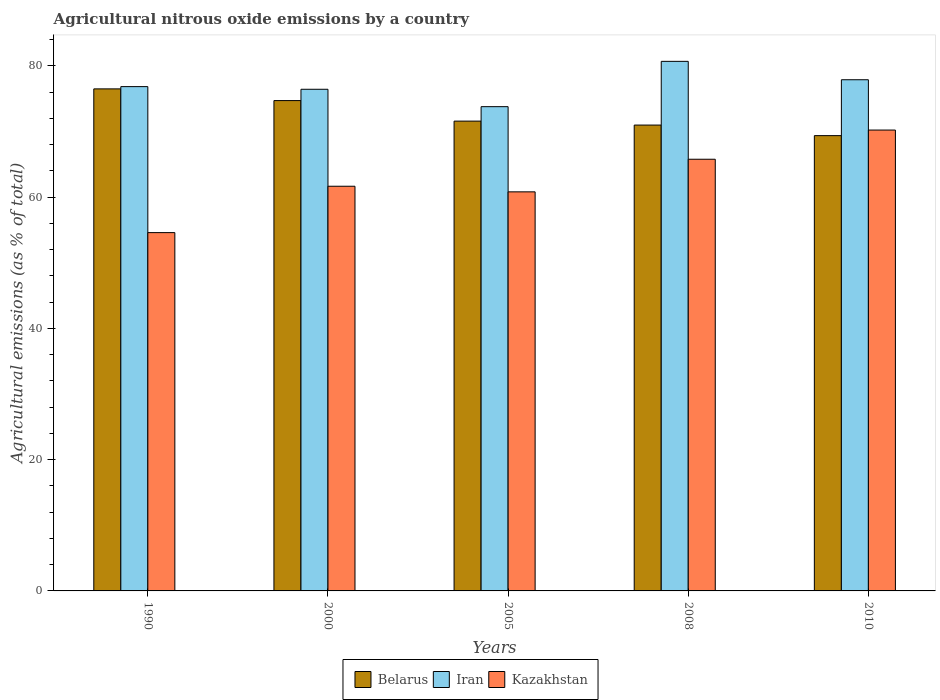How many different coloured bars are there?
Ensure brevity in your answer.  3. Are the number of bars per tick equal to the number of legend labels?
Offer a terse response. Yes. Are the number of bars on each tick of the X-axis equal?
Your answer should be compact. Yes. How many bars are there on the 2nd tick from the left?
Your answer should be compact. 3. How many bars are there on the 4th tick from the right?
Provide a short and direct response. 3. What is the amount of agricultural nitrous oxide emitted in Kazakhstan in 2008?
Your answer should be compact. 65.78. Across all years, what is the maximum amount of agricultural nitrous oxide emitted in Kazakhstan?
Give a very brief answer. 70.22. Across all years, what is the minimum amount of agricultural nitrous oxide emitted in Belarus?
Provide a succinct answer. 69.37. In which year was the amount of agricultural nitrous oxide emitted in Kazakhstan maximum?
Keep it short and to the point. 2010. What is the total amount of agricultural nitrous oxide emitted in Belarus in the graph?
Offer a terse response. 363.16. What is the difference between the amount of agricultural nitrous oxide emitted in Kazakhstan in 2000 and that in 2008?
Offer a terse response. -4.11. What is the difference between the amount of agricultural nitrous oxide emitted in Iran in 2000 and the amount of agricultural nitrous oxide emitted in Belarus in 2010?
Ensure brevity in your answer.  7.07. What is the average amount of agricultural nitrous oxide emitted in Kazakhstan per year?
Offer a terse response. 62.61. In the year 2008, what is the difference between the amount of agricultural nitrous oxide emitted in Kazakhstan and amount of agricultural nitrous oxide emitted in Belarus?
Your answer should be compact. -5.21. What is the ratio of the amount of agricultural nitrous oxide emitted in Belarus in 1990 to that in 2008?
Offer a very short reply. 1.08. Is the amount of agricultural nitrous oxide emitted in Kazakhstan in 2000 less than that in 2008?
Your response must be concise. Yes. What is the difference between the highest and the second highest amount of agricultural nitrous oxide emitted in Iran?
Offer a very short reply. 2.8. What is the difference between the highest and the lowest amount of agricultural nitrous oxide emitted in Kazakhstan?
Provide a succinct answer. 15.63. What does the 3rd bar from the left in 2000 represents?
Make the answer very short. Kazakhstan. What does the 3rd bar from the right in 2008 represents?
Provide a succinct answer. Belarus. How many bars are there?
Provide a short and direct response. 15. Are all the bars in the graph horizontal?
Provide a short and direct response. No. How many years are there in the graph?
Keep it short and to the point. 5. Are the values on the major ticks of Y-axis written in scientific E-notation?
Offer a terse response. No. Where does the legend appear in the graph?
Make the answer very short. Bottom center. How many legend labels are there?
Provide a succinct answer. 3. How are the legend labels stacked?
Keep it short and to the point. Horizontal. What is the title of the graph?
Give a very brief answer. Agricultural nitrous oxide emissions by a country. What is the label or title of the Y-axis?
Ensure brevity in your answer.  Agricultural emissions (as % of total). What is the Agricultural emissions (as % of total) in Belarus in 1990?
Your answer should be very brief. 76.5. What is the Agricultural emissions (as % of total) of Iran in 1990?
Give a very brief answer. 76.84. What is the Agricultural emissions (as % of total) in Kazakhstan in 1990?
Keep it short and to the point. 54.6. What is the Agricultural emissions (as % of total) in Belarus in 2000?
Your response must be concise. 74.72. What is the Agricultural emissions (as % of total) of Iran in 2000?
Your response must be concise. 76.44. What is the Agricultural emissions (as % of total) in Kazakhstan in 2000?
Ensure brevity in your answer.  61.66. What is the Agricultural emissions (as % of total) of Belarus in 2005?
Make the answer very short. 71.59. What is the Agricultural emissions (as % of total) in Iran in 2005?
Offer a terse response. 73.79. What is the Agricultural emissions (as % of total) of Kazakhstan in 2005?
Offer a terse response. 60.81. What is the Agricultural emissions (as % of total) in Belarus in 2008?
Keep it short and to the point. 70.98. What is the Agricultural emissions (as % of total) in Iran in 2008?
Your answer should be compact. 80.69. What is the Agricultural emissions (as % of total) in Kazakhstan in 2008?
Ensure brevity in your answer.  65.78. What is the Agricultural emissions (as % of total) in Belarus in 2010?
Provide a short and direct response. 69.37. What is the Agricultural emissions (as % of total) of Iran in 2010?
Ensure brevity in your answer.  77.89. What is the Agricultural emissions (as % of total) of Kazakhstan in 2010?
Ensure brevity in your answer.  70.22. Across all years, what is the maximum Agricultural emissions (as % of total) in Belarus?
Offer a very short reply. 76.5. Across all years, what is the maximum Agricultural emissions (as % of total) in Iran?
Keep it short and to the point. 80.69. Across all years, what is the maximum Agricultural emissions (as % of total) in Kazakhstan?
Your answer should be compact. 70.22. Across all years, what is the minimum Agricultural emissions (as % of total) of Belarus?
Make the answer very short. 69.37. Across all years, what is the minimum Agricultural emissions (as % of total) of Iran?
Keep it short and to the point. 73.79. Across all years, what is the minimum Agricultural emissions (as % of total) of Kazakhstan?
Provide a short and direct response. 54.6. What is the total Agricultural emissions (as % of total) in Belarus in the graph?
Give a very brief answer. 363.16. What is the total Agricultural emissions (as % of total) of Iran in the graph?
Provide a short and direct response. 385.66. What is the total Agricultural emissions (as % of total) of Kazakhstan in the graph?
Provide a short and direct response. 313.07. What is the difference between the Agricultural emissions (as % of total) in Belarus in 1990 and that in 2000?
Keep it short and to the point. 1.78. What is the difference between the Agricultural emissions (as % of total) of Iran in 1990 and that in 2000?
Ensure brevity in your answer.  0.4. What is the difference between the Agricultural emissions (as % of total) of Kazakhstan in 1990 and that in 2000?
Your answer should be compact. -7.07. What is the difference between the Agricultural emissions (as % of total) of Belarus in 1990 and that in 2005?
Make the answer very short. 4.91. What is the difference between the Agricultural emissions (as % of total) of Iran in 1990 and that in 2005?
Ensure brevity in your answer.  3.06. What is the difference between the Agricultural emissions (as % of total) in Kazakhstan in 1990 and that in 2005?
Your answer should be compact. -6.21. What is the difference between the Agricultural emissions (as % of total) of Belarus in 1990 and that in 2008?
Make the answer very short. 5.51. What is the difference between the Agricultural emissions (as % of total) in Iran in 1990 and that in 2008?
Keep it short and to the point. -3.85. What is the difference between the Agricultural emissions (as % of total) in Kazakhstan in 1990 and that in 2008?
Ensure brevity in your answer.  -11.18. What is the difference between the Agricultural emissions (as % of total) of Belarus in 1990 and that in 2010?
Your answer should be compact. 7.12. What is the difference between the Agricultural emissions (as % of total) in Iran in 1990 and that in 2010?
Provide a short and direct response. -1.05. What is the difference between the Agricultural emissions (as % of total) in Kazakhstan in 1990 and that in 2010?
Provide a succinct answer. -15.63. What is the difference between the Agricultural emissions (as % of total) in Belarus in 2000 and that in 2005?
Ensure brevity in your answer.  3.13. What is the difference between the Agricultural emissions (as % of total) of Iran in 2000 and that in 2005?
Provide a short and direct response. 2.65. What is the difference between the Agricultural emissions (as % of total) of Kazakhstan in 2000 and that in 2005?
Give a very brief answer. 0.86. What is the difference between the Agricultural emissions (as % of total) of Belarus in 2000 and that in 2008?
Make the answer very short. 3.73. What is the difference between the Agricultural emissions (as % of total) in Iran in 2000 and that in 2008?
Keep it short and to the point. -4.25. What is the difference between the Agricultural emissions (as % of total) in Kazakhstan in 2000 and that in 2008?
Provide a succinct answer. -4.11. What is the difference between the Agricultural emissions (as % of total) in Belarus in 2000 and that in 2010?
Offer a terse response. 5.34. What is the difference between the Agricultural emissions (as % of total) in Iran in 2000 and that in 2010?
Your answer should be compact. -1.45. What is the difference between the Agricultural emissions (as % of total) of Kazakhstan in 2000 and that in 2010?
Make the answer very short. -8.56. What is the difference between the Agricultural emissions (as % of total) in Belarus in 2005 and that in 2008?
Your response must be concise. 0.6. What is the difference between the Agricultural emissions (as % of total) of Iran in 2005 and that in 2008?
Offer a very short reply. -6.91. What is the difference between the Agricultural emissions (as % of total) of Kazakhstan in 2005 and that in 2008?
Offer a terse response. -4.97. What is the difference between the Agricultural emissions (as % of total) in Belarus in 2005 and that in 2010?
Ensure brevity in your answer.  2.21. What is the difference between the Agricultural emissions (as % of total) in Iran in 2005 and that in 2010?
Provide a succinct answer. -4.1. What is the difference between the Agricultural emissions (as % of total) in Kazakhstan in 2005 and that in 2010?
Provide a short and direct response. -9.42. What is the difference between the Agricultural emissions (as % of total) in Belarus in 2008 and that in 2010?
Give a very brief answer. 1.61. What is the difference between the Agricultural emissions (as % of total) in Iran in 2008 and that in 2010?
Offer a terse response. 2.8. What is the difference between the Agricultural emissions (as % of total) in Kazakhstan in 2008 and that in 2010?
Offer a very short reply. -4.45. What is the difference between the Agricultural emissions (as % of total) in Belarus in 1990 and the Agricultural emissions (as % of total) in Iran in 2000?
Your response must be concise. 0.06. What is the difference between the Agricultural emissions (as % of total) in Belarus in 1990 and the Agricultural emissions (as % of total) in Kazakhstan in 2000?
Your response must be concise. 14.84. What is the difference between the Agricultural emissions (as % of total) of Iran in 1990 and the Agricultural emissions (as % of total) of Kazakhstan in 2000?
Your answer should be very brief. 15.18. What is the difference between the Agricultural emissions (as % of total) in Belarus in 1990 and the Agricultural emissions (as % of total) in Iran in 2005?
Ensure brevity in your answer.  2.71. What is the difference between the Agricultural emissions (as % of total) in Belarus in 1990 and the Agricultural emissions (as % of total) in Kazakhstan in 2005?
Offer a terse response. 15.69. What is the difference between the Agricultural emissions (as % of total) in Iran in 1990 and the Agricultural emissions (as % of total) in Kazakhstan in 2005?
Offer a terse response. 16.04. What is the difference between the Agricultural emissions (as % of total) of Belarus in 1990 and the Agricultural emissions (as % of total) of Iran in 2008?
Offer a very short reply. -4.2. What is the difference between the Agricultural emissions (as % of total) in Belarus in 1990 and the Agricultural emissions (as % of total) in Kazakhstan in 2008?
Keep it short and to the point. 10.72. What is the difference between the Agricultural emissions (as % of total) of Iran in 1990 and the Agricultural emissions (as % of total) of Kazakhstan in 2008?
Give a very brief answer. 11.07. What is the difference between the Agricultural emissions (as % of total) in Belarus in 1990 and the Agricultural emissions (as % of total) in Iran in 2010?
Make the answer very short. -1.39. What is the difference between the Agricultural emissions (as % of total) of Belarus in 1990 and the Agricultural emissions (as % of total) of Kazakhstan in 2010?
Offer a terse response. 6.27. What is the difference between the Agricultural emissions (as % of total) of Iran in 1990 and the Agricultural emissions (as % of total) of Kazakhstan in 2010?
Ensure brevity in your answer.  6.62. What is the difference between the Agricultural emissions (as % of total) in Belarus in 2000 and the Agricultural emissions (as % of total) in Iran in 2005?
Ensure brevity in your answer.  0.93. What is the difference between the Agricultural emissions (as % of total) of Belarus in 2000 and the Agricultural emissions (as % of total) of Kazakhstan in 2005?
Your response must be concise. 13.91. What is the difference between the Agricultural emissions (as % of total) in Iran in 2000 and the Agricultural emissions (as % of total) in Kazakhstan in 2005?
Offer a terse response. 15.63. What is the difference between the Agricultural emissions (as % of total) of Belarus in 2000 and the Agricultural emissions (as % of total) of Iran in 2008?
Keep it short and to the point. -5.98. What is the difference between the Agricultural emissions (as % of total) in Belarus in 2000 and the Agricultural emissions (as % of total) in Kazakhstan in 2008?
Ensure brevity in your answer.  8.94. What is the difference between the Agricultural emissions (as % of total) in Iran in 2000 and the Agricultural emissions (as % of total) in Kazakhstan in 2008?
Keep it short and to the point. 10.66. What is the difference between the Agricultural emissions (as % of total) in Belarus in 2000 and the Agricultural emissions (as % of total) in Iran in 2010?
Your response must be concise. -3.18. What is the difference between the Agricultural emissions (as % of total) of Belarus in 2000 and the Agricultural emissions (as % of total) of Kazakhstan in 2010?
Offer a very short reply. 4.49. What is the difference between the Agricultural emissions (as % of total) in Iran in 2000 and the Agricultural emissions (as % of total) in Kazakhstan in 2010?
Make the answer very short. 6.22. What is the difference between the Agricultural emissions (as % of total) in Belarus in 2005 and the Agricultural emissions (as % of total) in Iran in 2008?
Your answer should be compact. -9.11. What is the difference between the Agricultural emissions (as % of total) in Belarus in 2005 and the Agricultural emissions (as % of total) in Kazakhstan in 2008?
Offer a very short reply. 5.81. What is the difference between the Agricultural emissions (as % of total) in Iran in 2005 and the Agricultural emissions (as % of total) in Kazakhstan in 2008?
Provide a short and direct response. 8.01. What is the difference between the Agricultural emissions (as % of total) in Belarus in 2005 and the Agricultural emissions (as % of total) in Iran in 2010?
Your answer should be compact. -6.3. What is the difference between the Agricultural emissions (as % of total) of Belarus in 2005 and the Agricultural emissions (as % of total) of Kazakhstan in 2010?
Offer a terse response. 1.36. What is the difference between the Agricultural emissions (as % of total) in Iran in 2005 and the Agricultural emissions (as % of total) in Kazakhstan in 2010?
Your response must be concise. 3.56. What is the difference between the Agricultural emissions (as % of total) in Belarus in 2008 and the Agricultural emissions (as % of total) in Iran in 2010?
Ensure brevity in your answer.  -6.91. What is the difference between the Agricultural emissions (as % of total) in Belarus in 2008 and the Agricultural emissions (as % of total) in Kazakhstan in 2010?
Your answer should be compact. 0.76. What is the difference between the Agricultural emissions (as % of total) of Iran in 2008 and the Agricultural emissions (as % of total) of Kazakhstan in 2010?
Your answer should be compact. 10.47. What is the average Agricultural emissions (as % of total) of Belarus per year?
Ensure brevity in your answer.  72.63. What is the average Agricultural emissions (as % of total) in Iran per year?
Offer a terse response. 77.13. What is the average Agricultural emissions (as % of total) in Kazakhstan per year?
Provide a short and direct response. 62.61. In the year 1990, what is the difference between the Agricultural emissions (as % of total) in Belarus and Agricultural emissions (as % of total) in Iran?
Keep it short and to the point. -0.35. In the year 1990, what is the difference between the Agricultural emissions (as % of total) of Belarus and Agricultural emissions (as % of total) of Kazakhstan?
Your answer should be compact. 21.9. In the year 1990, what is the difference between the Agricultural emissions (as % of total) in Iran and Agricultural emissions (as % of total) in Kazakhstan?
Your answer should be very brief. 22.25. In the year 2000, what is the difference between the Agricultural emissions (as % of total) of Belarus and Agricultural emissions (as % of total) of Iran?
Your response must be concise. -1.73. In the year 2000, what is the difference between the Agricultural emissions (as % of total) of Belarus and Agricultural emissions (as % of total) of Kazakhstan?
Make the answer very short. 13.05. In the year 2000, what is the difference between the Agricultural emissions (as % of total) of Iran and Agricultural emissions (as % of total) of Kazakhstan?
Provide a succinct answer. 14.78. In the year 2005, what is the difference between the Agricultural emissions (as % of total) in Belarus and Agricultural emissions (as % of total) in Iran?
Provide a short and direct response. -2.2. In the year 2005, what is the difference between the Agricultural emissions (as % of total) of Belarus and Agricultural emissions (as % of total) of Kazakhstan?
Offer a very short reply. 10.78. In the year 2005, what is the difference between the Agricultural emissions (as % of total) in Iran and Agricultural emissions (as % of total) in Kazakhstan?
Ensure brevity in your answer.  12.98. In the year 2008, what is the difference between the Agricultural emissions (as % of total) in Belarus and Agricultural emissions (as % of total) in Iran?
Provide a short and direct response. -9.71. In the year 2008, what is the difference between the Agricultural emissions (as % of total) of Belarus and Agricultural emissions (as % of total) of Kazakhstan?
Keep it short and to the point. 5.21. In the year 2008, what is the difference between the Agricultural emissions (as % of total) of Iran and Agricultural emissions (as % of total) of Kazakhstan?
Your answer should be very brief. 14.92. In the year 2010, what is the difference between the Agricultural emissions (as % of total) in Belarus and Agricultural emissions (as % of total) in Iran?
Offer a very short reply. -8.52. In the year 2010, what is the difference between the Agricultural emissions (as % of total) in Belarus and Agricultural emissions (as % of total) in Kazakhstan?
Your answer should be very brief. -0.85. In the year 2010, what is the difference between the Agricultural emissions (as % of total) in Iran and Agricultural emissions (as % of total) in Kazakhstan?
Ensure brevity in your answer.  7.67. What is the ratio of the Agricultural emissions (as % of total) of Belarus in 1990 to that in 2000?
Your answer should be compact. 1.02. What is the ratio of the Agricultural emissions (as % of total) of Iran in 1990 to that in 2000?
Provide a succinct answer. 1.01. What is the ratio of the Agricultural emissions (as % of total) of Kazakhstan in 1990 to that in 2000?
Your response must be concise. 0.89. What is the ratio of the Agricultural emissions (as % of total) in Belarus in 1990 to that in 2005?
Offer a terse response. 1.07. What is the ratio of the Agricultural emissions (as % of total) of Iran in 1990 to that in 2005?
Your answer should be very brief. 1.04. What is the ratio of the Agricultural emissions (as % of total) of Kazakhstan in 1990 to that in 2005?
Your response must be concise. 0.9. What is the ratio of the Agricultural emissions (as % of total) of Belarus in 1990 to that in 2008?
Keep it short and to the point. 1.08. What is the ratio of the Agricultural emissions (as % of total) of Iran in 1990 to that in 2008?
Keep it short and to the point. 0.95. What is the ratio of the Agricultural emissions (as % of total) in Kazakhstan in 1990 to that in 2008?
Ensure brevity in your answer.  0.83. What is the ratio of the Agricultural emissions (as % of total) of Belarus in 1990 to that in 2010?
Offer a terse response. 1.1. What is the ratio of the Agricultural emissions (as % of total) of Iran in 1990 to that in 2010?
Provide a short and direct response. 0.99. What is the ratio of the Agricultural emissions (as % of total) in Kazakhstan in 1990 to that in 2010?
Provide a short and direct response. 0.78. What is the ratio of the Agricultural emissions (as % of total) in Belarus in 2000 to that in 2005?
Provide a short and direct response. 1.04. What is the ratio of the Agricultural emissions (as % of total) in Iran in 2000 to that in 2005?
Give a very brief answer. 1.04. What is the ratio of the Agricultural emissions (as % of total) of Kazakhstan in 2000 to that in 2005?
Your response must be concise. 1.01. What is the ratio of the Agricultural emissions (as % of total) of Belarus in 2000 to that in 2008?
Provide a short and direct response. 1.05. What is the ratio of the Agricultural emissions (as % of total) in Iran in 2000 to that in 2008?
Your answer should be compact. 0.95. What is the ratio of the Agricultural emissions (as % of total) in Kazakhstan in 2000 to that in 2008?
Provide a succinct answer. 0.94. What is the ratio of the Agricultural emissions (as % of total) in Belarus in 2000 to that in 2010?
Your response must be concise. 1.08. What is the ratio of the Agricultural emissions (as % of total) in Iran in 2000 to that in 2010?
Provide a succinct answer. 0.98. What is the ratio of the Agricultural emissions (as % of total) in Kazakhstan in 2000 to that in 2010?
Offer a terse response. 0.88. What is the ratio of the Agricultural emissions (as % of total) of Belarus in 2005 to that in 2008?
Provide a succinct answer. 1.01. What is the ratio of the Agricultural emissions (as % of total) of Iran in 2005 to that in 2008?
Your answer should be compact. 0.91. What is the ratio of the Agricultural emissions (as % of total) in Kazakhstan in 2005 to that in 2008?
Offer a very short reply. 0.92. What is the ratio of the Agricultural emissions (as % of total) in Belarus in 2005 to that in 2010?
Give a very brief answer. 1.03. What is the ratio of the Agricultural emissions (as % of total) in Iran in 2005 to that in 2010?
Offer a very short reply. 0.95. What is the ratio of the Agricultural emissions (as % of total) in Kazakhstan in 2005 to that in 2010?
Offer a terse response. 0.87. What is the ratio of the Agricultural emissions (as % of total) of Belarus in 2008 to that in 2010?
Offer a terse response. 1.02. What is the ratio of the Agricultural emissions (as % of total) in Iran in 2008 to that in 2010?
Offer a terse response. 1.04. What is the ratio of the Agricultural emissions (as % of total) in Kazakhstan in 2008 to that in 2010?
Your response must be concise. 0.94. What is the difference between the highest and the second highest Agricultural emissions (as % of total) of Belarus?
Your answer should be compact. 1.78. What is the difference between the highest and the second highest Agricultural emissions (as % of total) of Iran?
Keep it short and to the point. 2.8. What is the difference between the highest and the second highest Agricultural emissions (as % of total) in Kazakhstan?
Offer a terse response. 4.45. What is the difference between the highest and the lowest Agricultural emissions (as % of total) of Belarus?
Give a very brief answer. 7.12. What is the difference between the highest and the lowest Agricultural emissions (as % of total) of Iran?
Provide a succinct answer. 6.91. What is the difference between the highest and the lowest Agricultural emissions (as % of total) of Kazakhstan?
Your answer should be very brief. 15.63. 